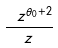Convert formula to latex. <formula><loc_0><loc_0><loc_500><loc_500>\frac { \ z ^ { \theta _ { 0 } + 2 } } { z }</formula> 